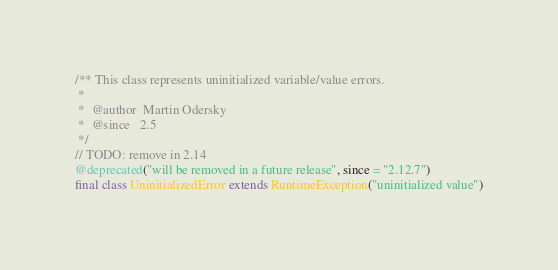<code> <loc_0><loc_0><loc_500><loc_500><_Scala_>
/** This class represents uninitialized variable/value errors.
 *
 *  @author  Martin Odersky
 *  @since   2.5
 */
// TODO: remove in 2.14
@deprecated("will be removed in a future release", since = "2.12.7")
final class UninitializedError extends RuntimeException("uninitialized value")
</code> 